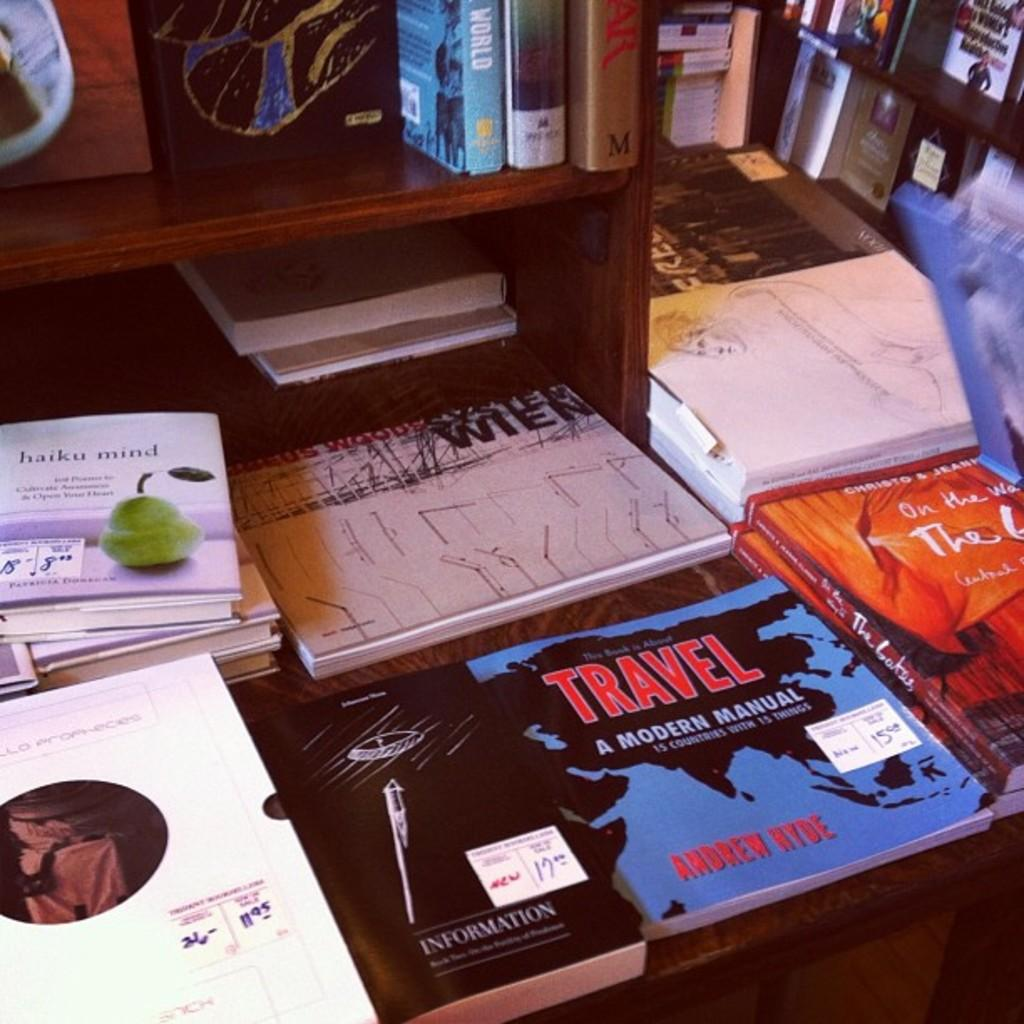Provide a one-sentence caption for the provided image. the word travel that is on a book. 